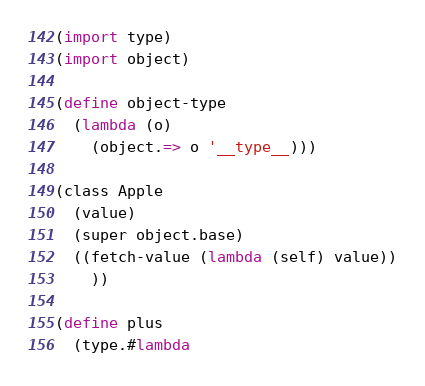Convert code to text. <code><loc_0><loc_0><loc_500><loc_500><_Scheme_>(import type)
(import object)

(define object-type
  (lambda (o)
    (object.=> o '__type__)))

(class Apple
  (value)
  (super object.base)
  ((fetch-value (lambda (self) value))
    ))
    
(define plus 
  (type.#lambda </code> 